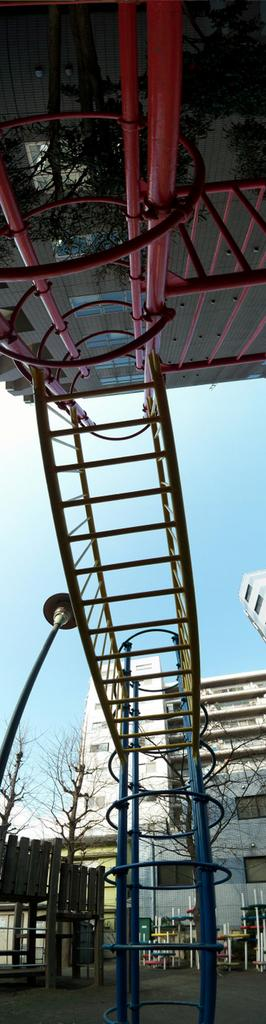What type of objects can be seen in the image? There are rods and metal objects in the image. What can be seen in the background of the image? There are trees, buildings, a pole, and metal objects in the background of the image. Additionally, there are clouds in the sky in the background. What type of territory is being claimed by the rods in the image? The rods in the image are not claiming any territory; they are simply objects in the image. 